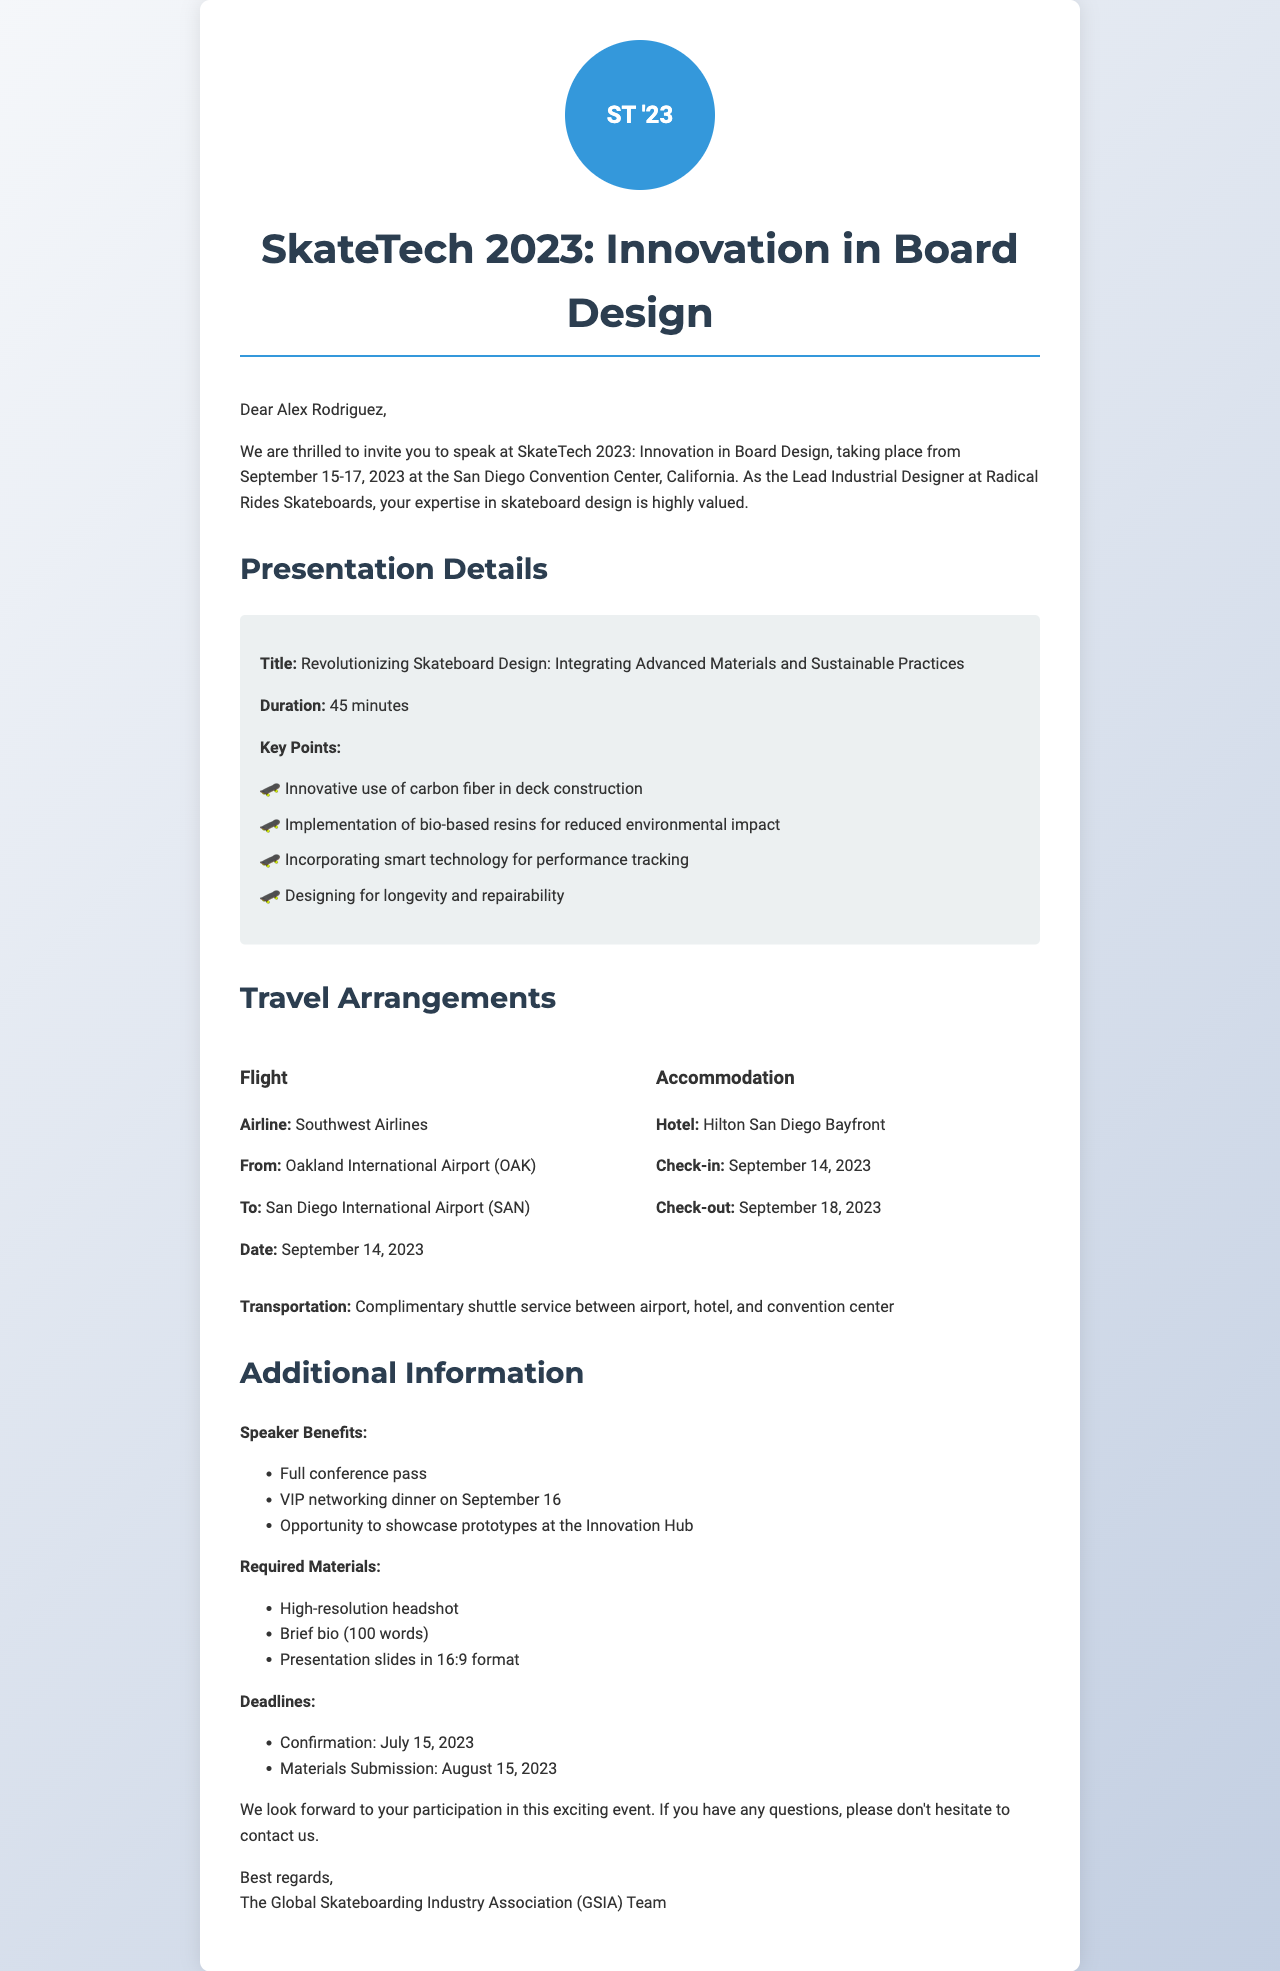What is the name of the conference? The name of the conference is stated in the document as SkateTech 2023: Innovation in Board Design.
Answer: SkateTech 2023: Innovation in Board Design What are the dates of the conference? The document specifies the conference dates from September 15 to September 17, 2023.
Answer: September 15-17, 2023 Who is the organizer of the conference? The organizer of the conference is mentioned in the document as the Global Skateboarding Industry Association (GSIA).
Answer: Global Skateboarding Industry Association (GSIA) What is the duration of the presentation? The duration of the presentation is detailed in the document as 45 minutes.
Answer: 45 minutes Which hotel will be used for accommodation? The document lists the Hilton San Diego Bayfront as the hotel for accommodation.
Answer: Hilton San Diego Bayfront What is one of the key points of the presentation? The document outlines several key points for the presentation, such as the innovative use of carbon fiber in deck construction.
Answer: Innovative use of carbon fiber in deck construction What is the required format for presentation slides? The required format for presentation slides is specified in the document as 16:9 format.
Answer: 16:9 format What is the confirmation deadline for the invitation? The document indicates that the confirmation deadline is July 15, 2023.
Answer: July 15, 2023 What type of transportation is provided? The document states that there will be complimentary shuttle service between the airport, hotel, and convention center.
Answer: Complimentary shuttle service 